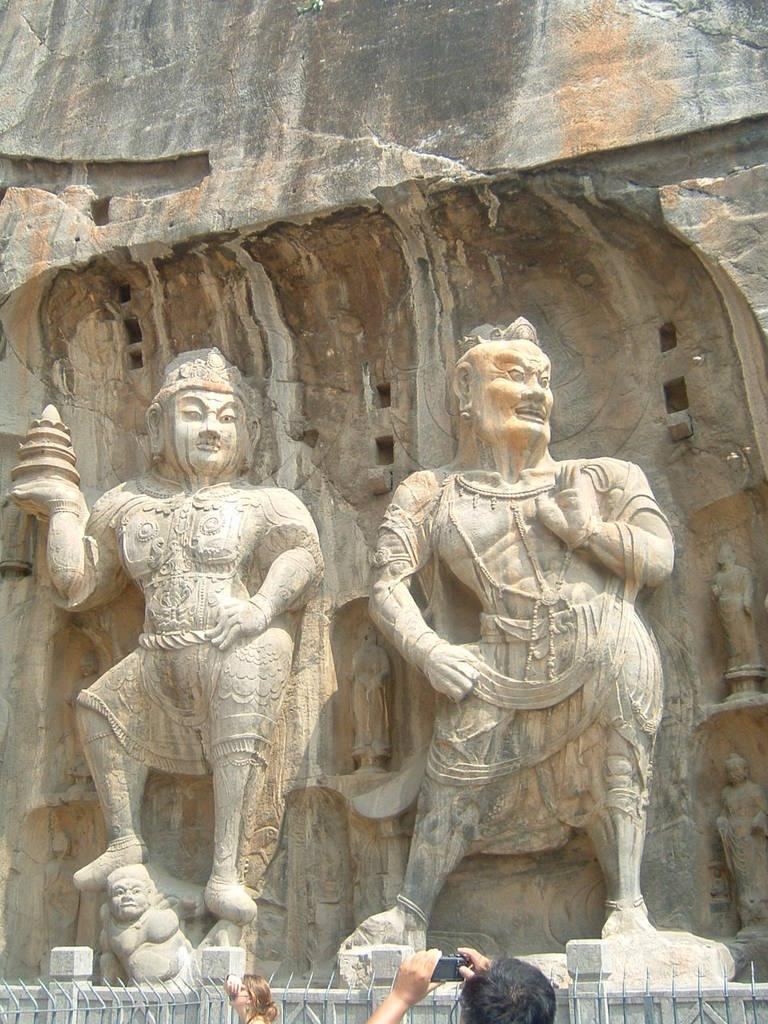How many sculptures are present in the image? There are three sculptures in the image. What else can be seen at the bottom of the image? There are two persons at the bottom of the image. What type of barrier is visible in the image? There is an iron fence in the image. What other structure is present in the image? There is a wall in the image. What might one of the persons be doing? One person is holding a camera. What type of flower is growing on the sculpture in the image? There are no flowers present on the sculptures in the image. 